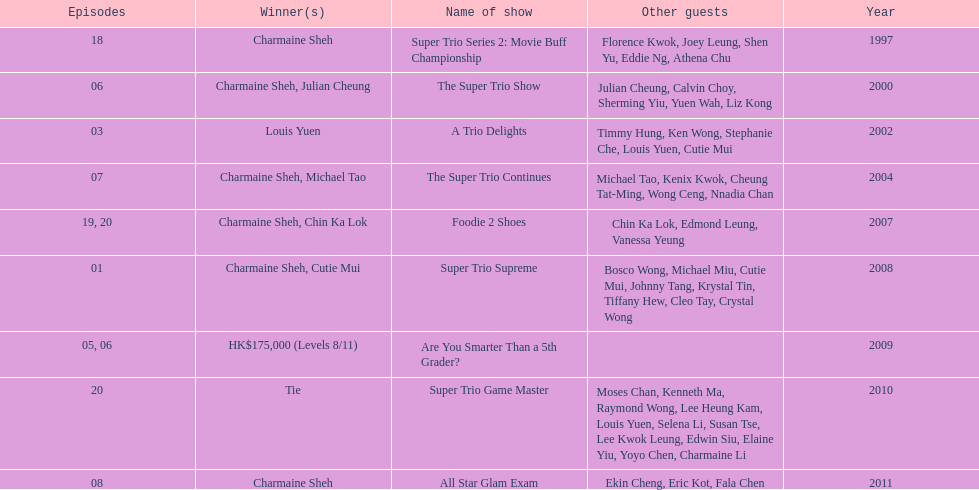How long has it been since chermaine sheh first appeared on a variety show? 17 years. 